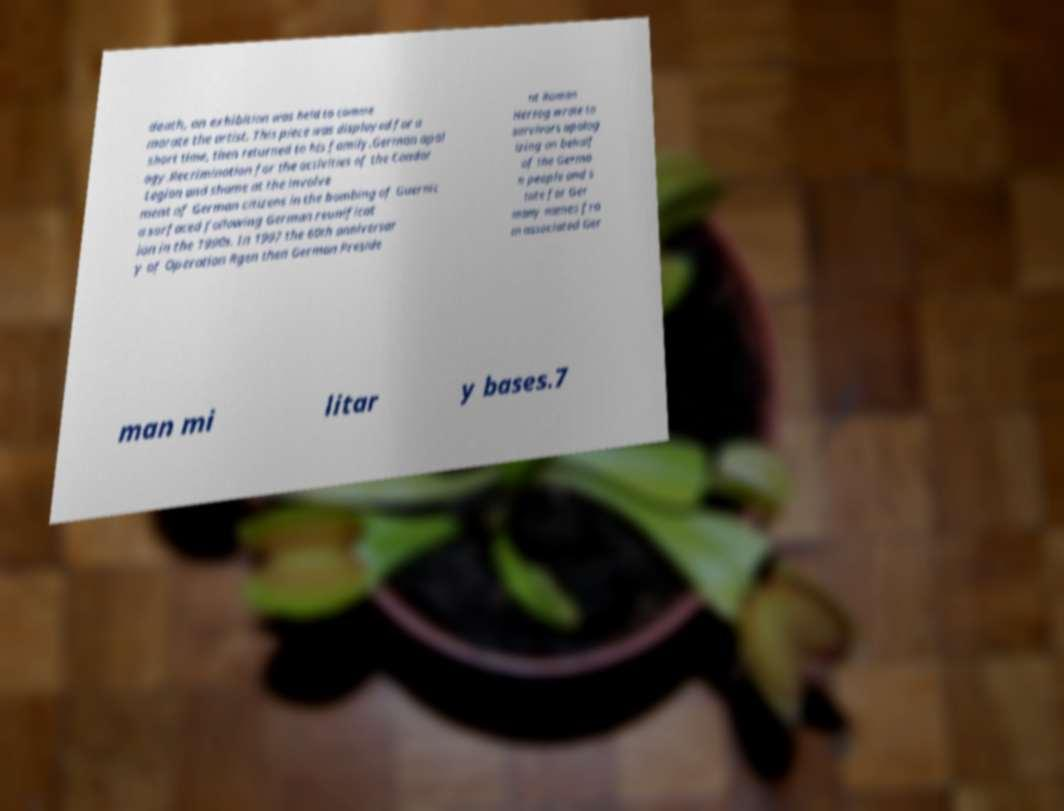Please identify and transcribe the text found in this image. death, an exhibition was held to comme morate the artist. This piece was displayed for a short time, then returned to his family.German apol ogy.Recrimination for the activities of the Condor Legion and shame at the involve ment of German citizens in the bombing of Guernic a surfaced following German reunificat ion in the 1990s. In 1997 the 60th anniversar y of Operation Rgen then German Preside nt Roman Herzog wrote to survivors apolog izing on behalf of the Germa n people and s tate for Ger many names fro m associated Ger man mi litar y bases.7 